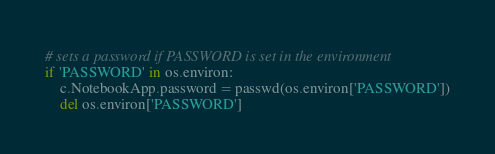Convert code to text. <code><loc_0><loc_0><loc_500><loc_500><_Python_>
# sets a password if PASSWORD is set in the environment
if 'PASSWORD' in os.environ:
    c.NotebookApp.password = passwd(os.environ['PASSWORD'])
    del os.environ['PASSWORD']
</code> 